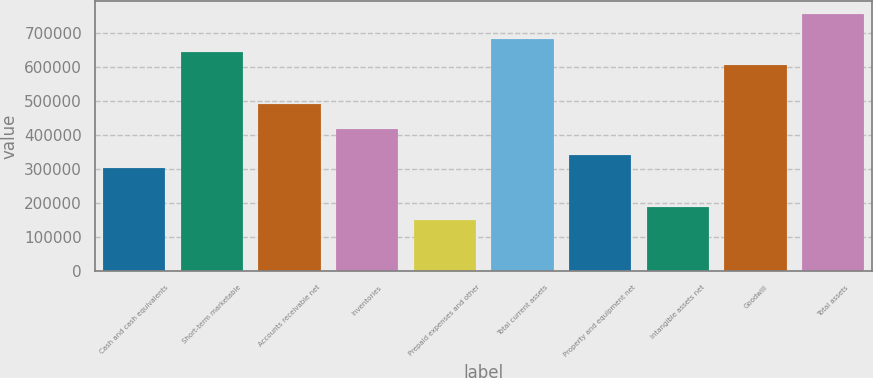Convert chart to OTSL. <chart><loc_0><loc_0><loc_500><loc_500><bar_chart><fcel>Cash and cash equivalents<fcel>Short-term marketable<fcel>Accounts receivable net<fcel>Inventories<fcel>Prepaid expenses and other<fcel>Total current assets<fcel>Property and equipment net<fcel>Intangible assets net<fcel>Goodwill<fcel>Total assets<nl><fcel>303450<fcel>644407<fcel>492870<fcel>417102<fcel>151913<fcel>682291<fcel>341334<fcel>189798<fcel>606523<fcel>758059<nl></chart> 